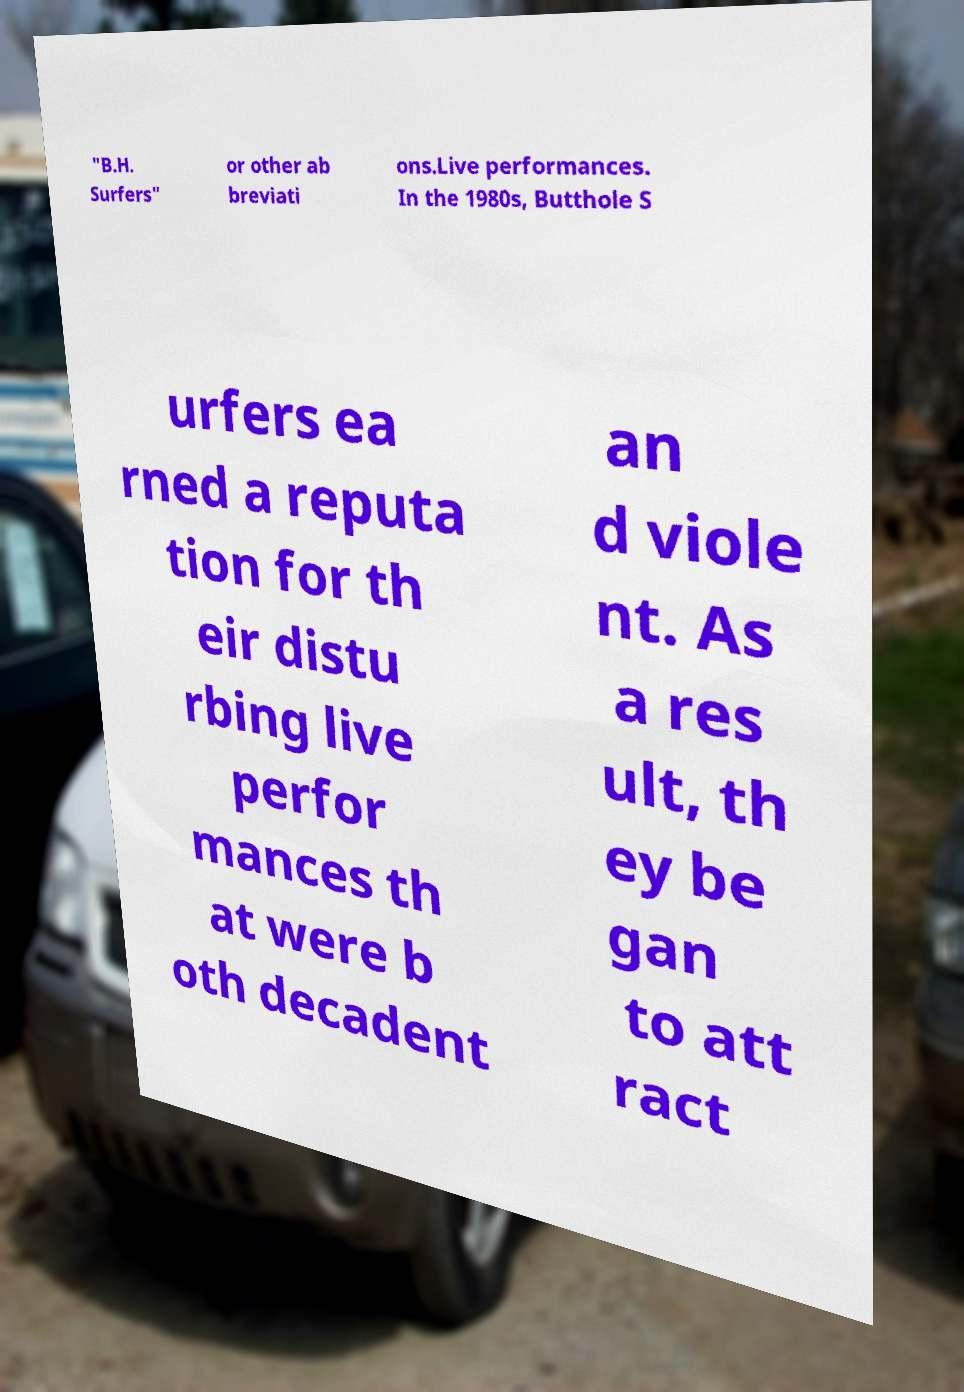Could you extract and type out the text from this image? "B.H. Surfers" or other ab breviati ons.Live performances. In the 1980s, Butthole S urfers ea rned a reputa tion for th eir distu rbing live perfor mances th at were b oth decadent an d viole nt. As a res ult, th ey be gan to att ract 